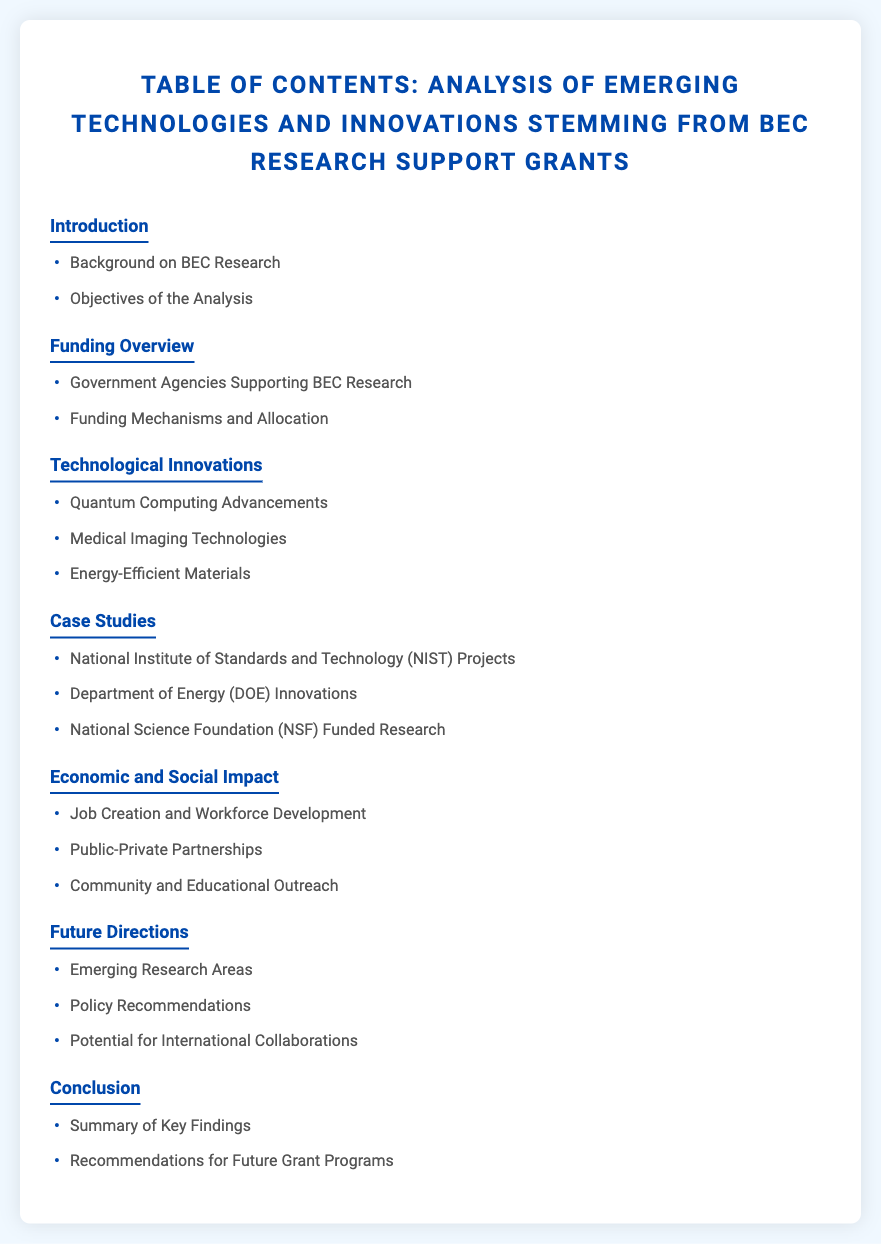What is the title of the document? The title is provided in the header of the document.
Answer: Analysis of Emerging Technologies and Innovations Stemming from BEC Research Support Grants What is the first subsection under the Introduction? The subsections under Introduction are listed, and the first is specified.
Answer: Background on BEC Research How many case studies are mentioned? The document lists several case studies, and the total can be counted.
Answer: 3 What government agency is associated with innovations in energy? The document specifies innovations related to specific agencies, including one focused on energy.
Answer: Department of Energy (DOE) What section discusses workforce development? The section explicitly includes various impacts, including workforce development.
Answer: Economic and Social Impact What is one area mentioned for future research directions? Future directions contain specific areas that are listed.
Answer: Emerging Research Areas Which section contains policy recommendations? Policy recommendations are included within a specific section as indicated in the TOC.
Answer: Future Directions What is the color of the section titles? The style of the document defines the color used for section titles.
Answer: #0047ab 